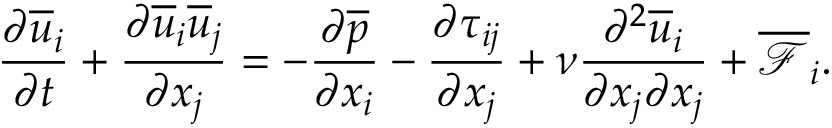Convert formula to latex. <formula><loc_0><loc_0><loc_500><loc_500>\frac { \partial \overline { u } _ { i } } { \partial t } + \frac { \partial \overline { u } _ { i } \overline { u } _ { j } } { \partial x _ { j } } = - \frac { \partial \overline { p } } { \partial x _ { i } } - \frac { \partial \tau _ { i j } } { \partial x _ { j } } + \nu \frac { \partial ^ { 2 } \overline { u } _ { i } } { \partial x _ { j } \partial x _ { j } } + \overline { { \mathcal { F } } } _ { i } .</formula> 